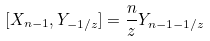Convert formula to latex. <formula><loc_0><loc_0><loc_500><loc_500>[ X _ { n - 1 } , Y _ { - 1 / z } ] = \frac { n } { z } Y _ { n - 1 - 1 / z }</formula> 